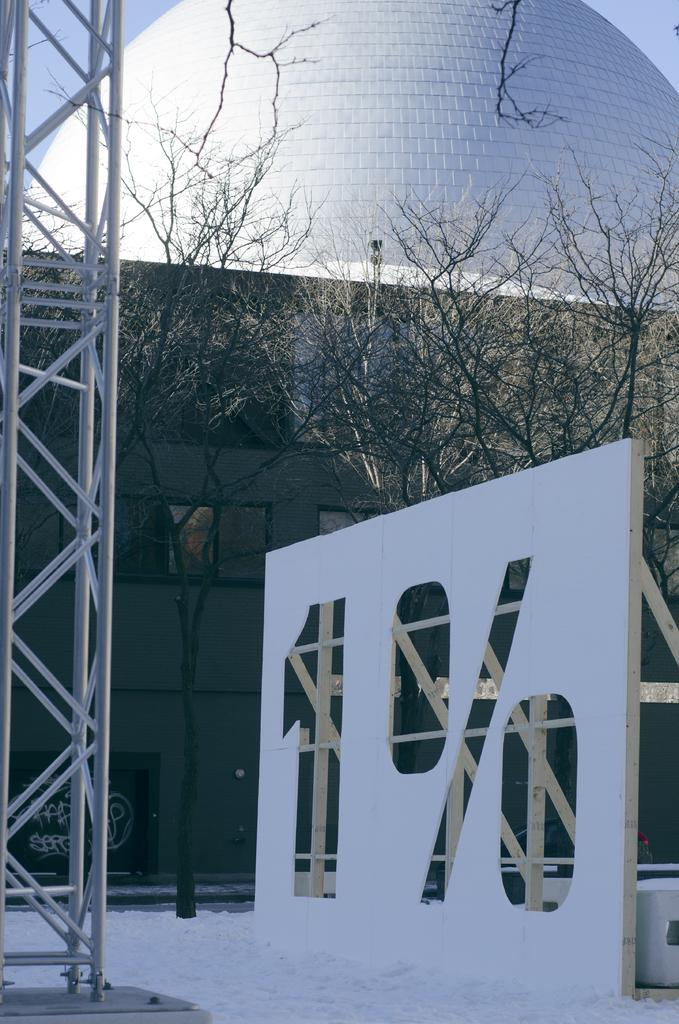What type of structure is visible in the image? There is a building in the image. What other natural elements can be seen in the image? There are trees in the image. What is the condition of the ground in the image? There is snow on the ground in the image. How would you describe the sky in the image? The sky is cloudy in the image. What object is located on the side of the image? There is a pole on the side of the image. What type of credit card is being used to purchase the books in the image? There are no credit cards or books present in the image; it features a building, trees, snow, a cloudy sky, and a pole. 